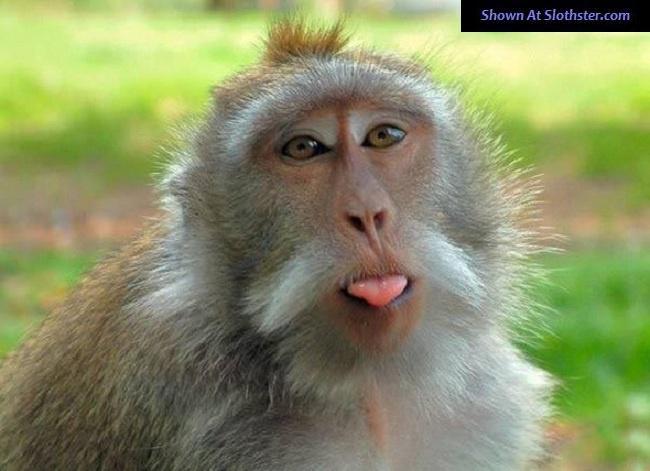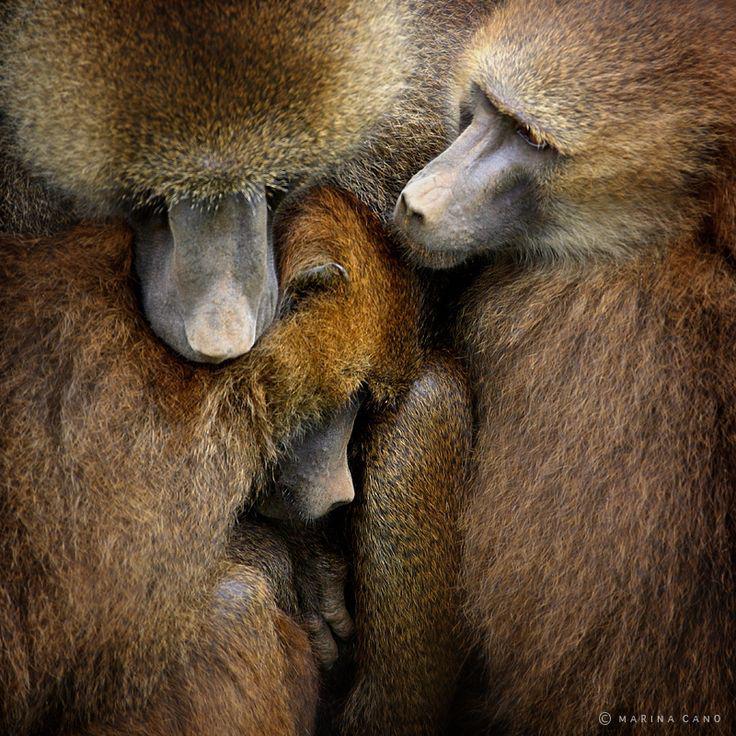The first image is the image on the left, the second image is the image on the right. Assess this claim about the two images: "there are three monkeys in the image to the right.". Correct or not? Answer yes or no. Yes. The first image is the image on the left, the second image is the image on the right. Evaluate the accuracy of this statement regarding the images: "The left image contains exactly one primate.". Is it true? Answer yes or no. Yes. 